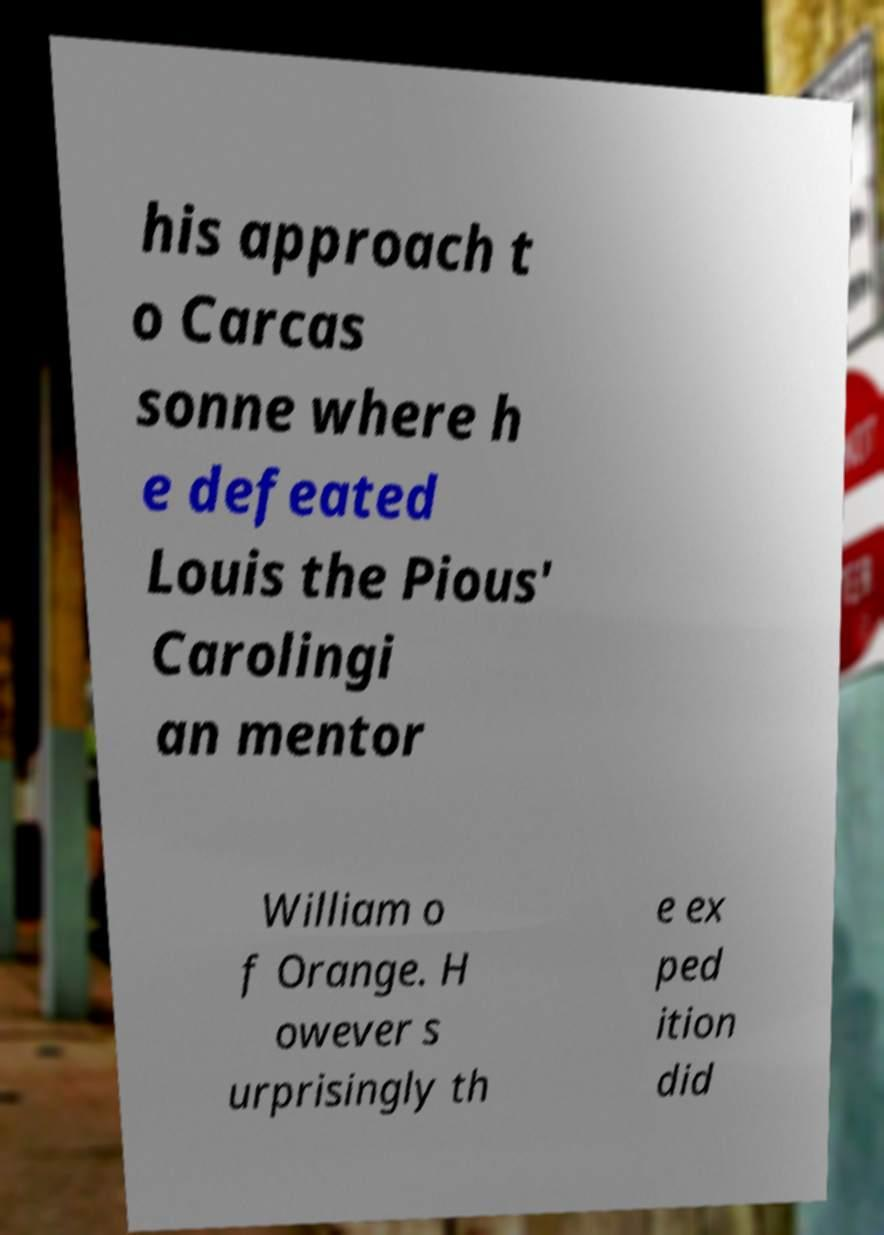Can you read and provide the text displayed in the image?This photo seems to have some interesting text. Can you extract and type it out for me? his approach t o Carcas sonne where h e defeated Louis the Pious' Carolingi an mentor William o f Orange. H owever s urprisingly th e ex ped ition did 